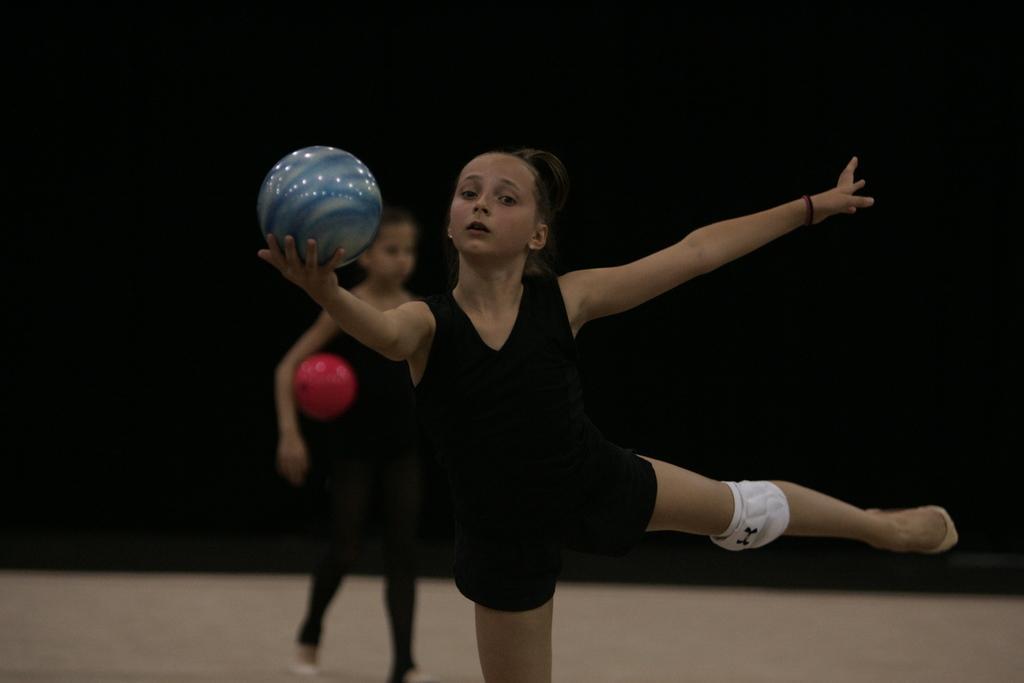Could you give a brief overview of what you see in this image? In this image we can see two girls playing with a ball on the ground. 